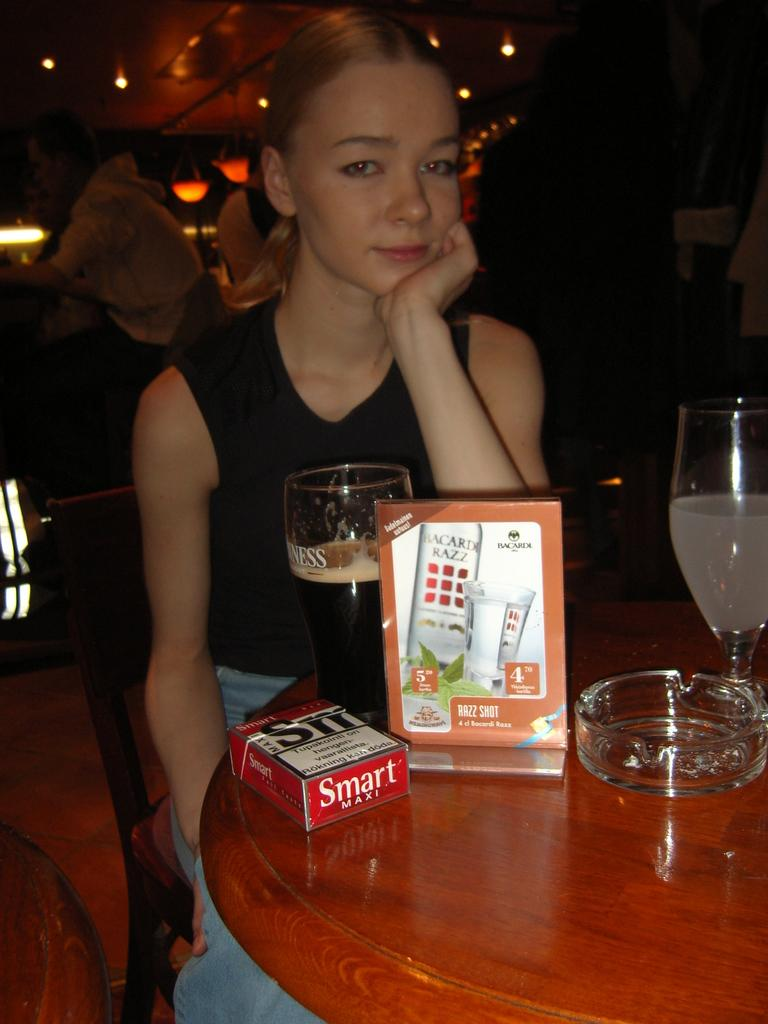What is the woman in the image doing? The woman is sitting in a chair. What is the woman looking at? The woman is looking at a side. What objects can be seen on the table in the image? There is a glass, a bowl, and a poster on the table. What is the purpose of the glass and bowl on the table? The glass and bowl on the table might be used for serving or holding food or drinks. What type of ear can be seen on the poster in the image? There is no ear present on the poster in the image; it is a glass, a bowl, and a poster on the table. What day of the week is depicted in the image? The image does not depict a specific day of the week; it shows a woman sitting in a chair, looking at a side, and objects on a table. 